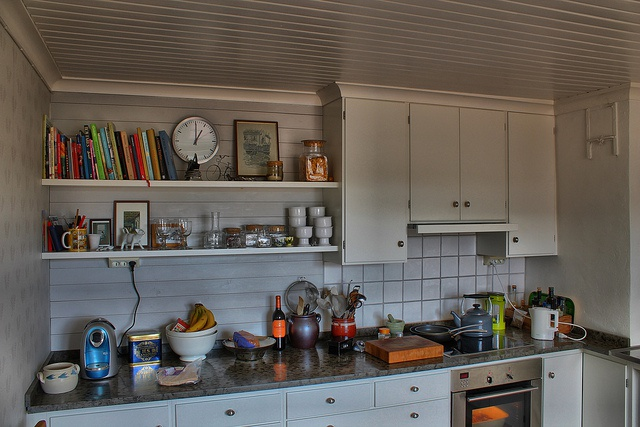Describe the objects in this image and their specific colors. I can see oven in gray and black tones, toaster in gray, black, and blue tones, bowl in gray, darkgray, maroon, and black tones, clock in gray and darkgray tones, and bowl in gray and black tones in this image. 